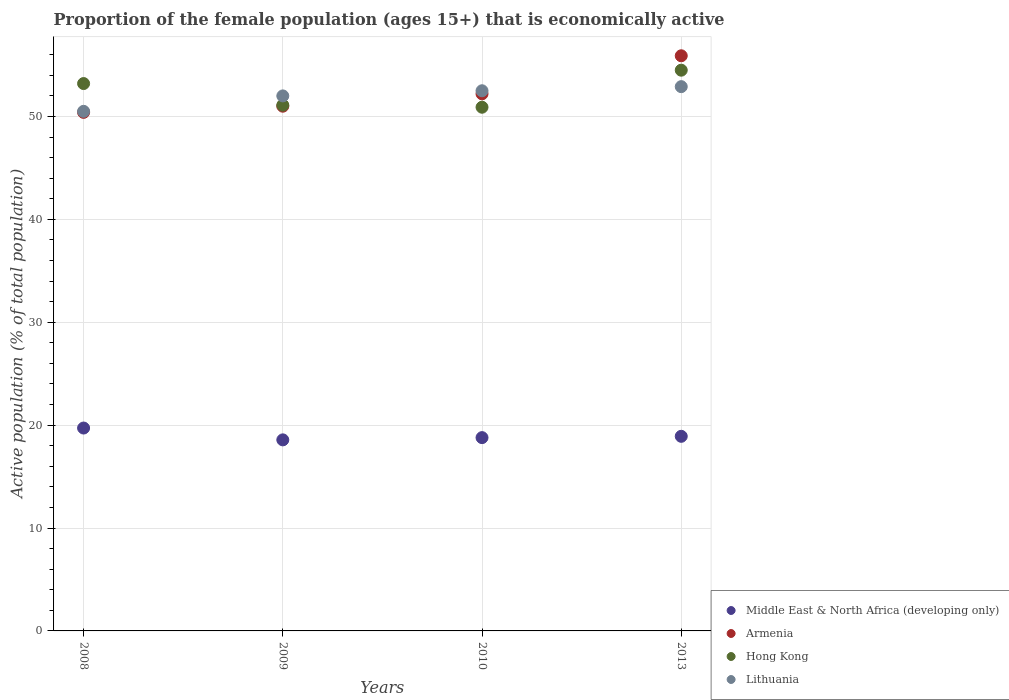How many different coloured dotlines are there?
Your answer should be very brief. 4. What is the proportion of the female population that is economically active in Hong Kong in 2009?
Provide a short and direct response. 51.1. Across all years, what is the maximum proportion of the female population that is economically active in Middle East & North Africa (developing only)?
Provide a succinct answer. 19.72. Across all years, what is the minimum proportion of the female population that is economically active in Armenia?
Ensure brevity in your answer.  50.4. What is the total proportion of the female population that is economically active in Hong Kong in the graph?
Your response must be concise. 209.7. What is the difference between the proportion of the female population that is economically active in Hong Kong in 2010 and that in 2013?
Provide a short and direct response. -3.6. What is the difference between the proportion of the female population that is economically active in Hong Kong in 2008 and the proportion of the female population that is economically active in Middle East & North Africa (developing only) in 2009?
Your answer should be compact. 34.63. What is the average proportion of the female population that is economically active in Middle East & North Africa (developing only) per year?
Provide a short and direct response. 19. In the year 2013, what is the difference between the proportion of the female population that is economically active in Hong Kong and proportion of the female population that is economically active in Armenia?
Provide a succinct answer. -1.4. In how many years, is the proportion of the female population that is economically active in Armenia greater than 52 %?
Ensure brevity in your answer.  2. What is the ratio of the proportion of the female population that is economically active in Lithuania in 2008 to that in 2013?
Your response must be concise. 0.95. What is the difference between the highest and the second highest proportion of the female population that is economically active in Hong Kong?
Your response must be concise. 1.3. What is the difference between the highest and the lowest proportion of the female population that is economically active in Armenia?
Your answer should be compact. 5.5. Is the sum of the proportion of the female population that is economically active in Lithuania in 2008 and 2009 greater than the maximum proportion of the female population that is economically active in Hong Kong across all years?
Offer a very short reply. Yes. Is it the case that in every year, the sum of the proportion of the female population that is economically active in Armenia and proportion of the female population that is economically active in Hong Kong  is greater than the sum of proportion of the female population that is economically active in Lithuania and proportion of the female population that is economically active in Middle East & North Africa (developing only)?
Your answer should be very brief. No. Is the proportion of the female population that is economically active in Middle East & North Africa (developing only) strictly greater than the proportion of the female population that is economically active in Armenia over the years?
Give a very brief answer. No. How many years are there in the graph?
Your response must be concise. 4. What is the difference between two consecutive major ticks on the Y-axis?
Your answer should be compact. 10. Does the graph contain any zero values?
Your response must be concise. No. Does the graph contain grids?
Provide a short and direct response. Yes. Where does the legend appear in the graph?
Your answer should be compact. Bottom right. How many legend labels are there?
Offer a terse response. 4. What is the title of the graph?
Your answer should be compact. Proportion of the female population (ages 15+) that is economically active. What is the label or title of the X-axis?
Provide a succinct answer. Years. What is the label or title of the Y-axis?
Ensure brevity in your answer.  Active population (% of total population). What is the Active population (% of total population) in Middle East & North Africa (developing only) in 2008?
Ensure brevity in your answer.  19.72. What is the Active population (% of total population) in Armenia in 2008?
Offer a terse response. 50.4. What is the Active population (% of total population) of Hong Kong in 2008?
Offer a very short reply. 53.2. What is the Active population (% of total population) in Lithuania in 2008?
Give a very brief answer. 50.5. What is the Active population (% of total population) in Middle East & North Africa (developing only) in 2009?
Ensure brevity in your answer.  18.57. What is the Active population (% of total population) of Armenia in 2009?
Offer a very short reply. 51. What is the Active population (% of total population) in Hong Kong in 2009?
Your answer should be very brief. 51.1. What is the Active population (% of total population) of Middle East & North Africa (developing only) in 2010?
Give a very brief answer. 18.79. What is the Active population (% of total population) of Armenia in 2010?
Your response must be concise. 52.2. What is the Active population (% of total population) in Hong Kong in 2010?
Provide a succinct answer. 50.9. What is the Active population (% of total population) in Lithuania in 2010?
Ensure brevity in your answer.  52.5. What is the Active population (% of total population) of Middle East & North Africa (developing only) in 2013?
Ensure brevity in your answer.  18.91. What is the Active population (% of total population) in Armenia in 2013?
Your response must be concise. 55.9. What is the Active population (% of total population) in Hong Kong in 2013?
Give a very brief answer. 54.5. What is the Active population (% of total population) in Lithuania in 2013?
Offer a very short reply. 52.9. Across all years, what is the maximum Active population (% of total population) in Middle East & North Africa (developing only)?
Your answer should be compact. 19.72. Across all years, what is the maximum Active population (% of total population) in Armenia?
Keep it short and to the point. 55.9. Across all years, what is the maximum Active population (% of total population) in Hong Kong?
Offer a very short reply. 54.5. Across all years, what is the maximum Active population (% of total population) in Lithuania?
Your answer should be very brief. 52.9. Across all years, what is the minimum Active population (% of total population) of Middle East & North Africa (developing only)?
Your answer should be compact. 18.57. Across all years, what is the minimum Active population (% of total population) in Armenia?
Keep it short and to the point. 50.4. Across all years, what is the minimum Active population (% of total population) in Hong Kong?
Your answer should be compact. 50.9. Across all years, what is the minimum Active population (% of total population) of Lithuania?
Give a very brief answer. 50.5. What is the total Active population (% of total population) in Middle East & North Africa (developing only) in the graph?
Provide a succinct answer. 75.99. What is the total Active population (% of total population) of Armenia in the graph?
Give a very brief answer. 209.5. What is the total Active population (% of total population) of Hong Kong in the graph?
Offer a terse response. 209.7. What is the total Active population (% of total population) of Lithuania in the graph?
Your answer should be compact. 207.9. What is the difference between the Active population (% of total population) in Middle East & North Africa (developing only) in 2008 and that in 2009?
Your answer should be compact. 1.15. What is the difference between the Active population (% of total population) in Hong Kong in 2008 and that in 2009?
Provide a succinct answer. 2.1. What is the difference between the Active population (% of total population) of Middle East & North Africa (developing only) in 2008 and that in 2010?
Ensure brevity in your answer.  0.93. What is the difference between the Active population (% of total population) of Middle East & North Africa (developing only) in 2008 and that in 2013?
Your answer should be compact. 0.8. What is the difference between the Active population (% of total population) in Armenia in 2008 and that in 2013?
Provide a short and direct response. -5.5. What is the difference between the Active population (% of total population) of Lithuania in 2008 and that in 2013?
Your answer should be very brief. -2.4. What is the difference between the Active population (% of total population) of Middle East & North Africa (developing only) in 2009 and that in 2010?
Your answer should be very brief. -0.22. What is the difference between the Active population (% of total population) in Lithuania in 2009 and that in 2010?
Make the answer very short. -0.5. What is the difference between the Active population (% of total population) in Middle East & North Africa (developing only) in 2009 and that in 2013?
Offer a terse response. -0.34. What is the difference between the Active population (% of total population) in Armenia in 2009 and that in 2013?
Your answer should be compact. -4.9. What is the difference between the Active population (% of total population) of Hong Kong in 2009 and that in 2013?
Your answer should be compact. -3.4. What is the difference between the Active population (% of total population) of Lithuania in 2009 and that in 2013?
Provide a short and direct response. -0.9. What is the difference between the Active population (% of total population) in Middle East & North Africa (developing only) in 2010 and that in 2013?
Your response must be concise. -0.13. What is the difference between the Active population (% of total population) of Lithuania in 2010 and that in 2013?
Give a very brief answer. -0.4. What is the difference between the Active population (% of total population) of Middle East & North Africa (developing only) in 2008 and the Active population (% of total population) of Armenia in 2009?
Provide a short and direct response. -31.28. What is the difference between the Active population (% of total population) of Middle East & North Africa (developing only) in 2008 and the Active population (% of total population) of Hong Kong in 2009?
Offer a very short reply. -31.38. What is the difference between the Active population (% of total population) of Middle East & North Africa (developing only) in 2008 and the Active population (% of total population) of Lithuania in 2009?
Offer a very short reply. -32.28. What is the difference between the Active population (% of total population) of Armenia in 2008 and the Active population (% of total population) of Lithuania in 2009?
Provide a succinct answer. -1.6. What is the difference between the Active population (% of total population) of Middle East & North Africa (developing only) in 2008 and the Active population (% of total population) of Armenia in 2010?
Your answer should be very brief. -32.48. What is the difference between the Active population (% of total population) of Middle East & North Africa (developing only) in 2008 and the Active population (% of total population) of Hong Kong in 2010?
Provide a succinct answer. -31.18. What is the difference between the Active population (% of total population) in Middle East & North Africa (developing only) in 2008 and the Active population (% of total population) in Lithuania in 2010?
Offer a very short reply. -32.78. What is the difference between the Active population (% of total population) in Armenia in 2008 and the Active population (% of total population) in Hong Kong in 2010?
Ensure brevity in your answer.  -0.5. What is the difference between the Active population (% of total population) in Armenia in 2008 and the Active population (% of total population) in Lithuania in 2010?
Your answer should be very brief. -2.1. What is the difference between the Active population (% of total population) of Hong Kong in 2008 and the Active population (% of total population) of Lithuania in 2010?
Keep it short and to the point. 0.7. What is the difference between the Active population (% of total population) of Middle East & North Africa (developing only) in 2008 and the Active population (% of total population) of Armenia in 2013?
Provide a succinct answer. -36.18. What is the difference between the Active population (% of total population) in Middle East & North Africa (developing only) in 2008 and the Active population (% of total population) in Hong Kong in 2013?
Provide a succinct answer. -34.78. What is the difference between the Active population (% of total population) of Middle East & North Africa (developing only) in 2008 and the Active population (% of total population) of Lithuania in 2013?
Provide a succinct answer. -33.18. What is the difference between the Active population (% of total population) of Middle East & North Africa (developing only) in 2009 and the Active population (% of total population) of Armenia in 2010?
Your answer should be very brief. -33.63. What is the difference between the Active population (% of total population) in Middle East & North Africa (developing only) in 2009 and the Active population (% of total population) in Hong Kong in 2010?
Offer a terse response. -32.33. What is the difference between the Active population (% of total population) in Middle East & North Africa (developing only) in 2009 and the Active population (% of total population) in Lithuania in 2010?
Make the answer very short. -33.93. What is the difference between the Active population (% of total population) in Armenia in 2009 and the Active population (% of total population) in Lithuania in 2010?
Provide a succinct answer. -1.5. What is the difference between the Active population (% of total population) in Middle East & North Africa (developing only) in 2009 and the Active population (% of total population) in Armenia in 2013?
Offer a terse response. -37.33. What is the difference between the Active population (% of total population) in Middle East & North Africa (developing only) in 2009 and the Active population (% of total population) in Hong Kong in 2013?
Make the answer very short. -35.93. What is the difference between the Active population (% of total population) of Middle East & North Africa (developing only) in 2009 and the Active population (% of total population) of Lithuania in 2013?
Make the answer very short. -34.33. What is the difference between the Active population (% of total population) in Armenia in 2009 and the Active population (% of total population) in Hong Kong in 2013?
Keep it short and to the point. -3.5. What is the difference between the Active population (% of total population) in Armenia in 2009 and the Active population (% of total population) in Lithuania in 2013?
Provide a succinct answer. -1.9. What is the difference between the Active population (% of total population) of Hong Kong in 2009 and the Active population (% of total population) of Lithuania in 2013?
Give a very brief answer. -1.8. What is the difference between the Active population (% of total population) in Middle East & North Africa (developing only) in 2010 and the Active population (% of total population) in Armenia in 2013?
Offer a terse response. -37.11. What is the difference between the Active population (% of total population) of Middle East & North Africa (developing only) in 2010 and the Active population (% of total population) of Hong Kong in 2013?
Give a very brief answer. -35.71. What is the difference between the Active population (% of total population) in Middle East & North Africa (developing only) in 2010 and the Active population (% of total population) in Lithuania in 2013?
Offer a very short reply. -34.11. What is the difference between the Active population (% of total population) of Armenia in 2010 and the Active population (% of total population) of Hong Kong in 2013?
Your answer should be very brief. -2.3. What is the difference between the Active population (% of total population) in Armenia in 2010 and the Active population (% of total population) in Lithuania in 2013?
Offer a terse response. -0.7. What is the difference between the Active population (% of total population) of Hong Kong in 2010 and the Active population (% of total population) of Lithuania in 2013?
Offer a very short reply. -2. What is the average Active population (% of total population) of Middle East & North Africa (developing only) per year?
Make the answer very short. 19. What is the average Active population (% of total population) of Armenia per year?
Offer a very short reply. 52.38. What is the average Active population (% of total population) in Hong Kong per year?
Make the answer very short. 52.42. What is the average Active population (% of total population) in Lithuania per year?
Offer a very short reply. 51.98. In the year 2008, what is the difference between the Active population (% of total population) in Middle East & North Africa (developing only) and Active population (% of total population) in Armenia?
Give a very brief answer. -30.68. In the year 2008, what is the difference between the Active population (% of total population) of Middle East & North Africa (developing only) and Active population (% of total population) of Hong Kong?
Your answer should be compact. -33.48. In the year 2008, what is the difference between the Active population (% of total population) in Middle East & North Africa (developing only) and Active population (% of total population) in Lithuania?
Offer a very short reply. -30.78. In the year 2009, what is the difference between the Active population (% of total population) of Middle East & North Africa (developing only) and Active population (% of total population) of Armenia?
Your response must be concise. -32.43. In the year 2009, what is the difference between the Active population (% of total population) in Middle East & North Africa (developing only) and Active population (% of total population) in Hong Kong?
Provide a succinct answer. -32.53. In the year 2009, what is the difference between the Active population (% of total population) of Middle East & North Africa (developing only) and Active population (% of total population) of Lithuania?
Your response must be concise. -33.43. In the year 2009, what is the difference between the Active population (% of total population) in Hong Kong and Active population (% of total population) in Lithuania?
Ensure brevity in your answer.  -0.9. In the year 2010, what is the difference between the Active population (% of total population) in Middle East & North Africa (developing only) and Active population (% of total population) in Armenia?
Your answer should be compact. -33.41. In the year 2010, what is the difference between the Active population (% of total population) in Middle East & North Africa (developing only) and Active population (% of total population) in Hong Kong?
Your response must be concise. -32.11. In the year 2010, what is the difference between the Active population (% of total population) of Middle East & North Africa (developing only) and Active population (% of total population) of Lithuania?
Your answer should be very brief. -33.71. In the year 2013, what is the difference between the Active population (% of total population) of Middle East & North Africa (developing only) and Active population (% of total population) of Armenia?
Your response must be concise. -36.99. In the year 2013, what is the difference between the Active population (% of total population) of Middle East & North Africa (developing only) and Active population (% of total population) of Hong Kong?
Provide a succinct answer. -35.59. In the year 2013, what is the difference between the Active population (% of total population) in Middle East & North Africa (developing only) and Active population (% of total population) in Lithuania?
Offer a very short reply. -33.99. What is the ratio of the Active population (% of total population) of Middle East & North Africa (developing only) in 2008 to that in 2009?
Offer a terse response. 1.06. What is the ratio of the Active population (% of total population) in Armenia in 2008 to that in 2009?
Ensure brevity in your answer.  0.99. What is the ratio of the Active population (% of total population) in Hong Kong in 2008 to that in 2009?
Provide a short and direct response. 1.04. What is the ratio of the Active population (% of total population) in Lithuania in 2008 to that in 2009?
Give a very brief answer. 0.97. What is the ratio of the Active population (% of total population) of Middle East & North Africa (developing only) in 2008 to that in 2010?
Offer a terse response. 1.05. What is the ratio of the Active population (% of total population) of Armenia in 2008 to that in 2010?
Make the answer very short. 0.97. What is the ratio of the Active population (% of total population) of Hong Kong in 2008 to that in 2010?
Keep it short and to the point. 1.05. What is the ratio of the Active population (% of total population) in Lithuania in 2008 to that in 2010?
Keep it short and to the point. 0.96. What is the ratio of the Active population (% of total population) in Middle East & North Africa (developing only) in 2008 to that in 2013?
Your response must be concise. 1.04. What is the ratio of the Active population (% of total population) of Armenia in 2008 to that in 2013?
Ensure brevity in your answer.  0.9. What is the ratio of the Active population (% of total population) of Hong Kong in 2008 to that in 2013?
Your response must be concise. 0.98. What is the ratio of the Active population (% of total population) of Lithuania in 2008 to that in 2013?
Provide a succinct answer. 0.95. What is the ratio of the Active population (% of total population) of Middle East & North Africa (developing only) in 2009 to that in 2010?
Give a very brief answer. 0.99. What is the ratio of the Active population (% of total population) of Armenia in 2009 to that in 2010?
Keep it short and to the point. 0.98. What is the ratio of the Active population (% of total population) of Lithuania in 2009 to that in 2010?
Your answer should be very brief. 0.99. What is the ratio of the Active population (% of total population) in Middle East & North Africa (developing only) in 2009 to that in 2013?
Your answer should be compact. 0.98. What is the ratio of the Active population (% of total population) in Armenia in 2009 to that in 2013?
Your answer should be compact. 0.91. What is the ratio of the Active population (% of total population) in Hong Kong in 2009 to that in 2013?
Offer a terse response. 0.94. What is the ratio of the Active population (% of total population) of Middle East & North Africa (developing only) in 2010 to that in 2013?
Provide a succinct answer. 0.99. What is the ratio of the Active population (% of total population) in Armenia in 2010 to that in 2013?
Your response must be concise. 0.93. What is the ratio of the Active population (% of total population) in Hong Kong in 2010 to that in 2013?
Make the answer very short. 0.93. What is the ratio of the Active population (% of total population) of Lithuania in 2010 to that in 2013?
Make the answer very short. 0.99. What is the difference between the highest and the second highest Active population (% of total population) in Middle East & North Africa (developing only)?
Provide a short and direct response. 0.8. What is the difference between the highest and the second highest Active population (% of total population) of Armenia?
Your answer should be compact. 3.7. What is the difference between the highest and the second highest Active population (% of total population) in Lithuania?
Your answer should be very brief. 0.4. What is the difference between the highest and the lowest Active population (% of total population) in Middle East & North Africa (developing only)?
Your response must be concise. 1.15. What is the difference between the highest and the lowest Active population (% of total population) of Armenia?
Offer a very short reply. 5.5. What is the difference between the highest and the lowest Active population (% of total population) in Hong Kong?
Offer a very short reply. 3.6. 